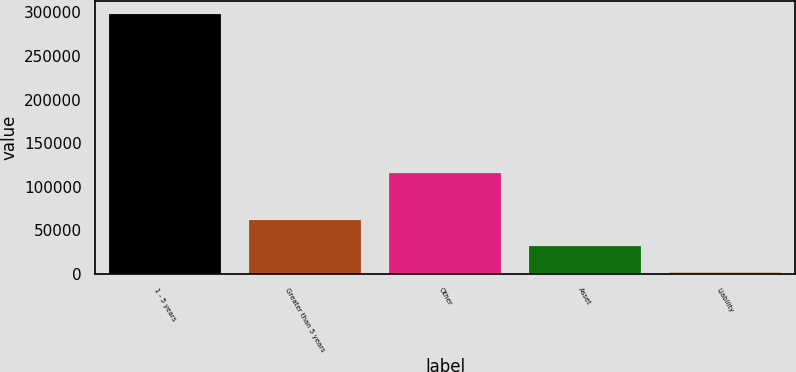Convert chart to OTSL. <chart><loc_0><loc_0><loc_500><loc_500><bar_chart><fcel>1 - 5 years<fcel>Greater than 5 years<fcel>Other<fcel>Asset<fcel>Liability<nl><fcel>298228<fcel>61237.6<fcel>115754<fcel>31613.8<fcel>1990<nl></chart> 